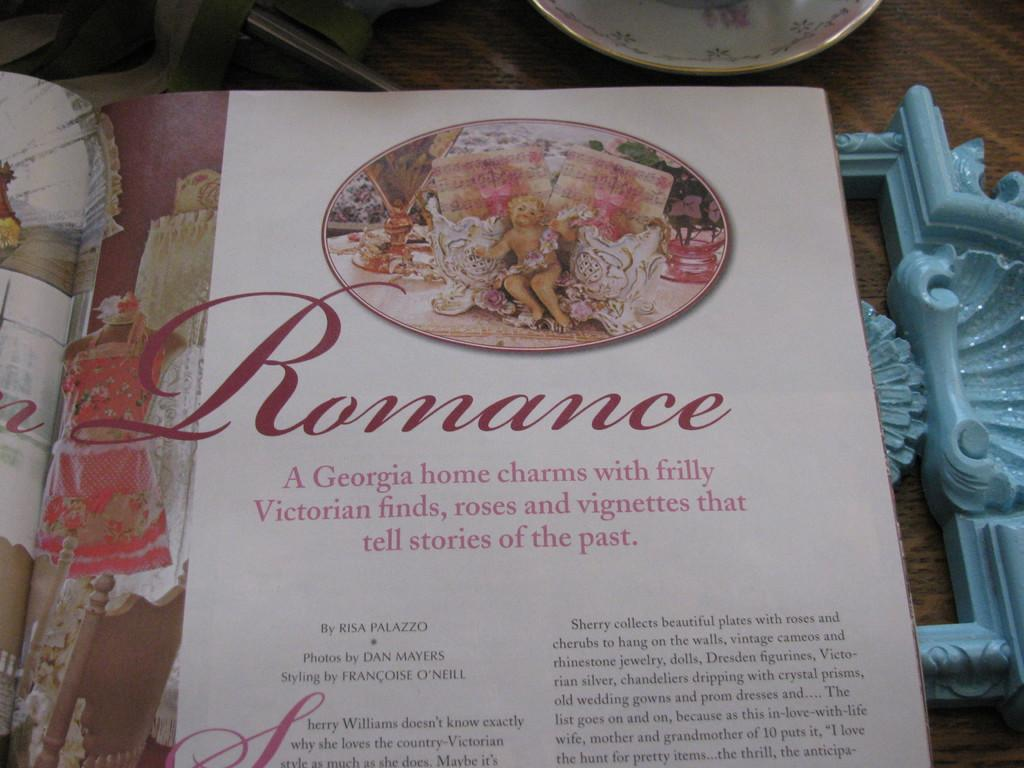What is the color of the page in the image? The page in the image is white-colored. What can be seen on the white-colored page? Something is written on the white-colored page. What is the color of the object in the image? The object in the image is blue-colored. Can you describe the background of the image? There is a plate visible in the background of the image. What type of weather is depicted in the image? There is no weather depicted in the image; it is a still image of a white-colored page, a blue-colored object, and a plate can be observed. 